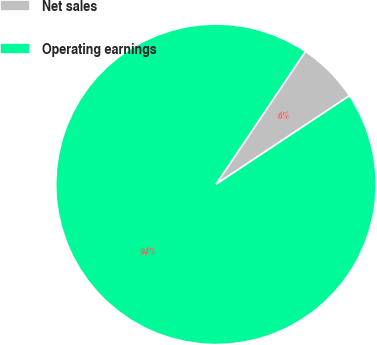<chart> <loc_0><loc_0><loc_500><loc_500><pie_chart><fcel>Net sales<fcel>Operating earnings<nl><fcel>6.25%<fcel>93.75%<nl></chart> 